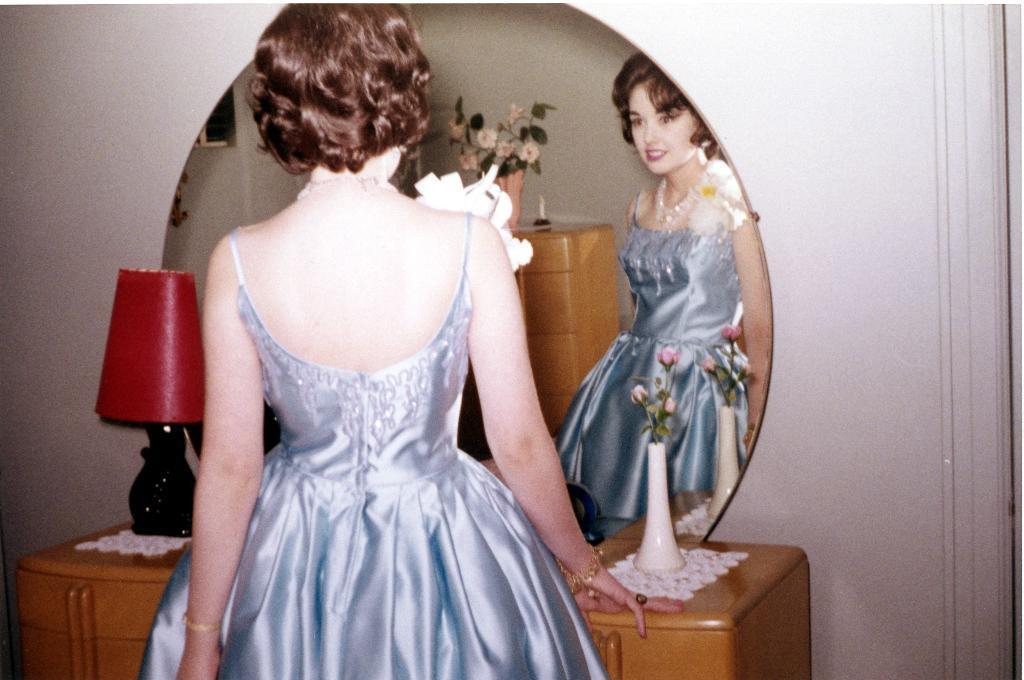Please provide a concise description of this image. In this image there is a girl, in front of her there is a dressing table, on that there is a mirror in that mirror she is reflecting, in the background there is a wall. 